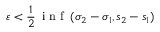<formula> <loc_0><loc_0><loc_500><loc_500>\varepsilon < \frac { 1 } { 2 } \, i n f \, ( \sigma _ { 2 } - \sigma _ { 1 } , s _ { 2 } - s _ { 1 } )</formula> 